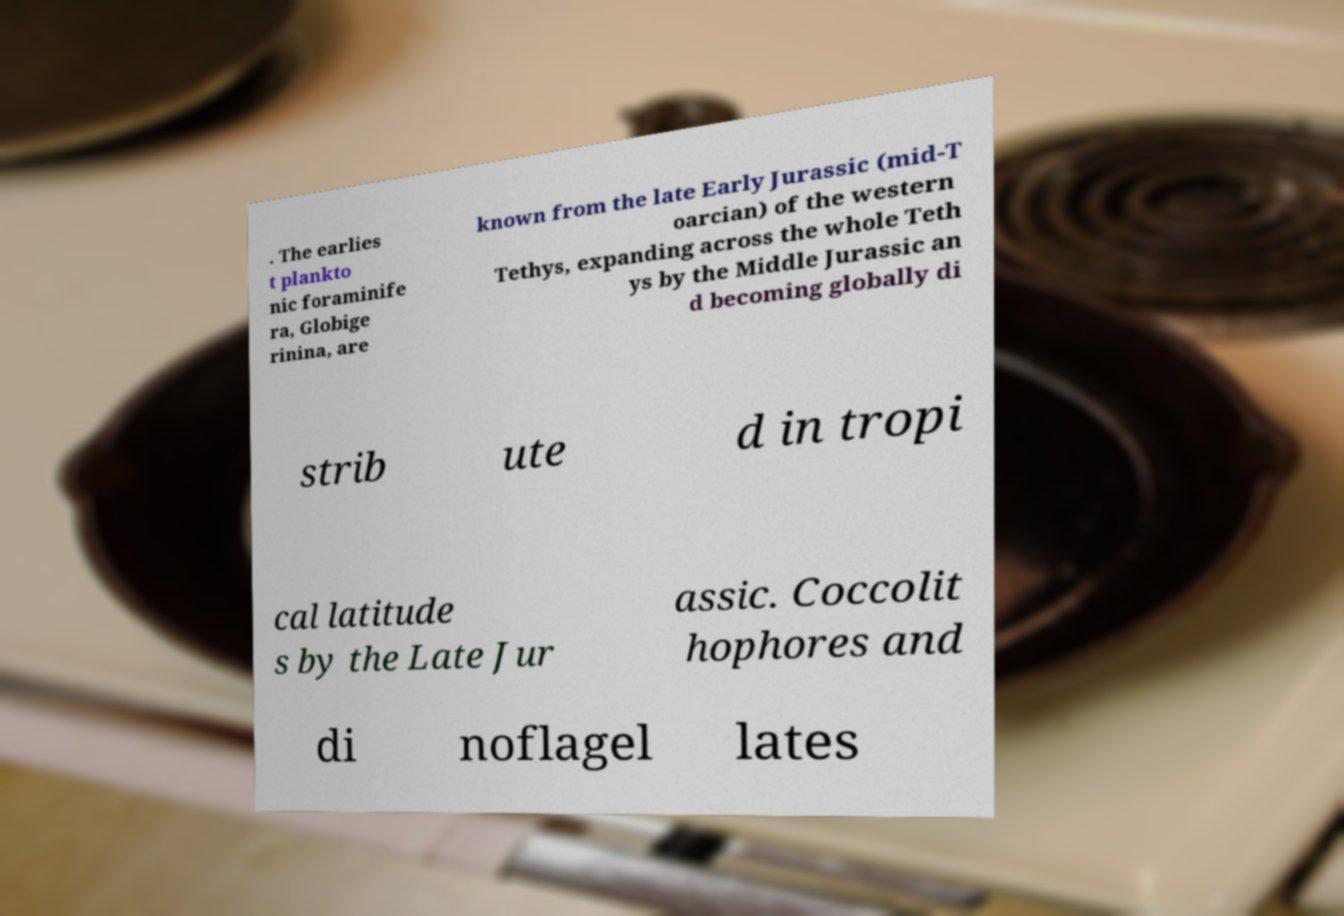Please identify and transcribe the text found in this image. . The earlies t plankto nic foraminife ra, Globige rinina, are known from the late Early Jurassic (mid-T oarcian) of the western Tethys, expanding across the whole Teth ys by the Middle Jurassic an d becoming globally di strib ute d in tropi cal latitude s by the Late Jur assic. Coccolit hophores and di noflagel lates 